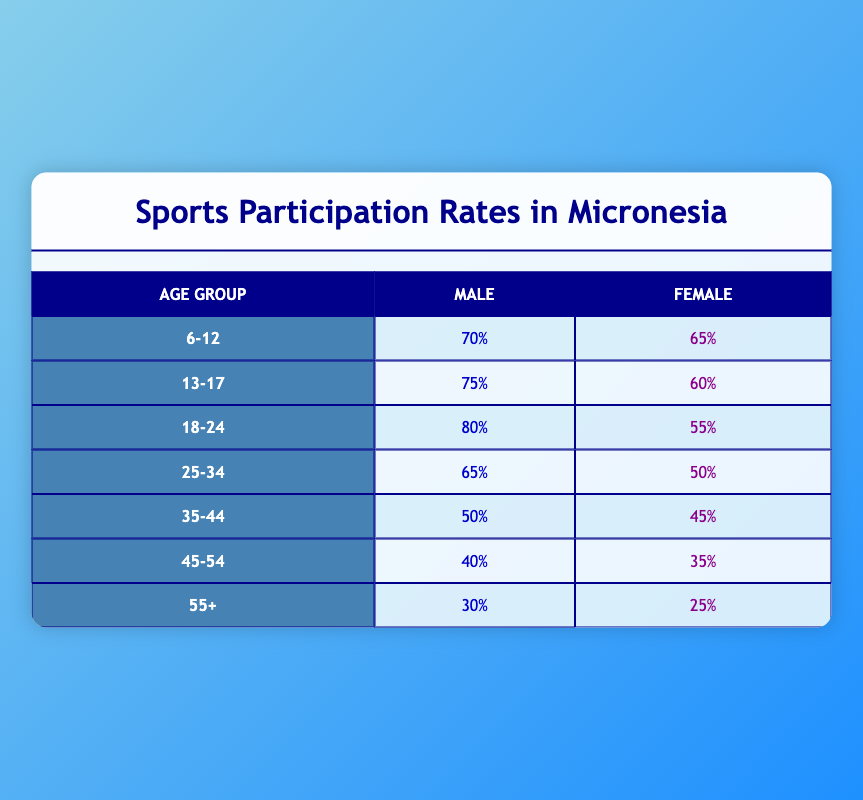What is the sports participation rate for males aged 6-12? The table shows that for the age group 6-12, the participation rate for males is listed directly as 70%.
Answer: 70% What is the sports participation rate for females aged 18-24? According to the table, the participation rate for females in the age group 18-24 is specified as 55%.
Answer: 55% What age group has the highest participation rate for males? By examining the table, we see that the age group 18-24 has the highest participation rate for males, which is 80%.
Answer: 18-24, 80% What is the difference in participation rates between males and females aged 25-34? From the table, we find that the participation rate for males in the age group 25-34 is 65%, and for females, it is 50%. The difference is calculated as 65% - 50% = 15%.
Answer: 15% Are there more females participating in sports than males in the age group 35-44? The table indicates that the participation rate for males aged 35-44 is 50% while for females it is 45%. Since 50% is greater than 45%, the answer is no.
Answer: No What is the average sports participation rate for the age group 45-54 across both genders? Looking at the table, the participation rate for males is 40% and for females is 35%. To find the average, we add these values (40% + 35%) and divide by 2: (75% / 2) = 37.5%.
Answer: 37.5% For which age group is the female participation rate the lowest? In the table, the lowest female participation rate is found in the 55+ age group, where it is 25%. This can be concluded by checking all the rates for females in each age group.
Answer: 55+, 25% Is the participation rate for males aged 18-24 greater than the participation rate for females in the same age group? The table shows that the participation rate for males aged 18-24 is 80%, while for females in the same group it is 55%. Since 80% is greater than 55%, the answer is yes.
Answer: Yes How does the sports participation rate for males aged 45-54 compare to that of females in the same age group? Referring to the table, the participation rate for males aged 45-54 is 40%, while for females it is 35%. Since 40% is greater than 35%, that means males have a higher participation rate.
Answer: Males have a higher rate 